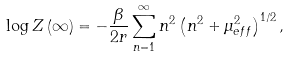<formula> <loc_0><loc_0><loc_500><loc_500>\log Z \left ( \infty \right ) = - \frac { \beta } { 2 r } \sum _ { n = 1 } ^ { \infty } n ^ { 2 } \left ( n ^ { 2 } + \mu _ { e f f } ^ { 2 } \right ) ^ { 1 / 2 } ,</formula> 